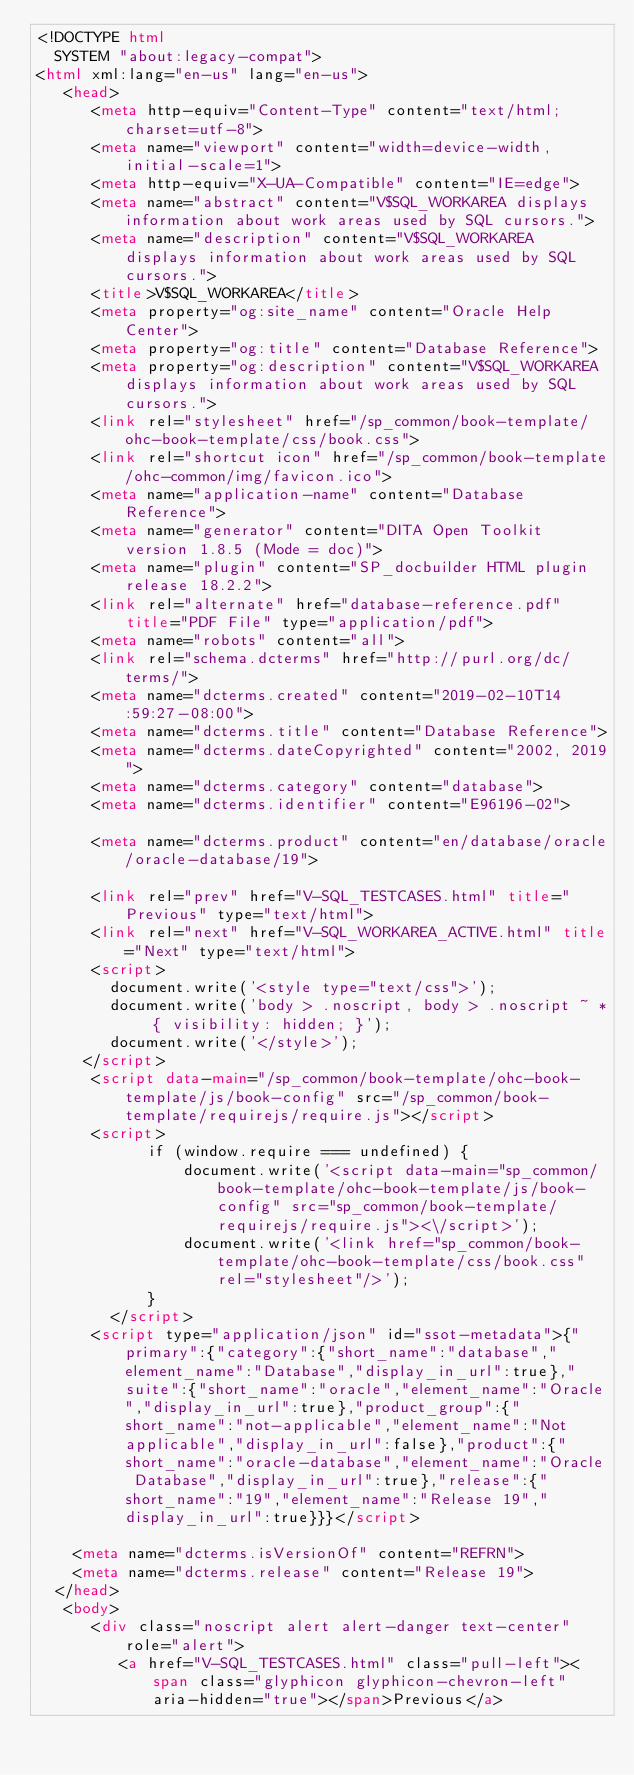<code> <loc_0><loc_0><loc_500><loc_500><_HTML_><!DOCTYPE html
  SYSTEM "about:legacy-compat">
<html xml:lang="en-us" lang="en-us">
   <head>
      <meta http-equiv="Content-Type" content="text/html; charset=utf-8">
      <meta name="viewport" content="width=device-width, initial-scale=1">
      <meta http-equiv="X-UA-Compatible" content="IE=edge">
      <meta name="abstract" content="V$SQL_WORKAREA displays information about work areas used by SQL cursors.">
      <meta name="description" content="V$SQL_WORKAREA displays information about work areas used by SQL cursors.">
      <title>V$SQL_WORKAREA</title>
      <meta property="og:site_name" content="Oracle Help Center">
      <meta property="og:title" content="Database Reference">
      <meta property="og:description" content="V$SQL_WORKAREA displays information about work areas used by SQL cursors.">
      <link rel="stylesheet" href="/sp_common/book-template/ohc-book-template/css/book.css">
      <link rel="shortcut icon" href="/sp_common/book-template/ohc-common/img/favicon.ico">
      <meta name="application-name" content="Database Reference">
      <meta name="generator" content="DITA Open Toolkit version 1.8.5 (Mode = doc)">
      <meta name="plugin" content="SP_docbuilder HTML plugin release 18.2.2">
      <link rel="alternate" href="database-reference.pdf" title="PDF File" type="application/pdf">
      <meta name="robots" content="all">
      <link rel="schema.dcterms" href="http://purl.org/dc/terms/">
      <meta name="dcterms.created" content="2019-02-10T14:59:27-08:00">
      <meta name="dcterms.title" content="Database Reference">
      <meta name="dcterms.dateCopyrighted" content="2002, 2019">
      <meta name="dcterms.category" content="database">
      <meta name="dcterms.identifier" content="E96196-02">
      
      <meta name="dcterms.product" content="en/database/oracle/oracle-database/19">
      
      <link rel="prev" href="V-SQL_TESTCASES.html" title="Previous" type="text/html">
      <link rel="next" href="V-SQL_WORKAREA_ACTIVE.html" title="Next" type="text/html">
      <script>
        document.write('<style type="text/css">');
        document.write('body > .noscript, body > .noscript ~ * { visibility: hidden; }');
        document.write('</style>');
     </script>
      <script data-main="/sp_common/book-template/ohc-book-template/js/book-config" src="/sp_common/book-template/requirejs/require.js"></script>
      <script>
            if (window.require === undefined) {
                document.write('<script data-main="sp_common/book-template/ohc-book-template/js/book-config" src="sp_common/book-template/requirejs/require.js"><\/script>');
                document.write('<link href="sp_common/book-template/ohc-book-template/css/book.css" rel="stylesheet"/>');
            }
        </script>
      <script type="application/json" id="ssot-metadata">{"primary":{"category":{"short_name":"database","element_name":"Database","display_in_url":true},"suite":{"short_name":"oracle","element_name":"Oracle","display_in_url":true},"product_group":{"short_name":"not-applicable","element_name":"Not applicable","display_in_url":false},"product":{"short_name":"oracle-database","element_name":"Oracle Database","display_in_url":true},"release":{"short_name":"19","element_name":"Release 19","display_in_url":true}}}</script>
      
    <meta name="dcterms.isVersionOf" content="REFRN">
    <meta name="dcterms.release" content="Release 19">
  </head>
   <body>
      <div class="noscript alert alert-danger text-center" role="alert">
         <a href="V-SQL_TESTCASES.html" class="pull-left"><span class="glyphicon glyphicon-chevron-left" aria-hidden="true"></span>Previous</a></code> 